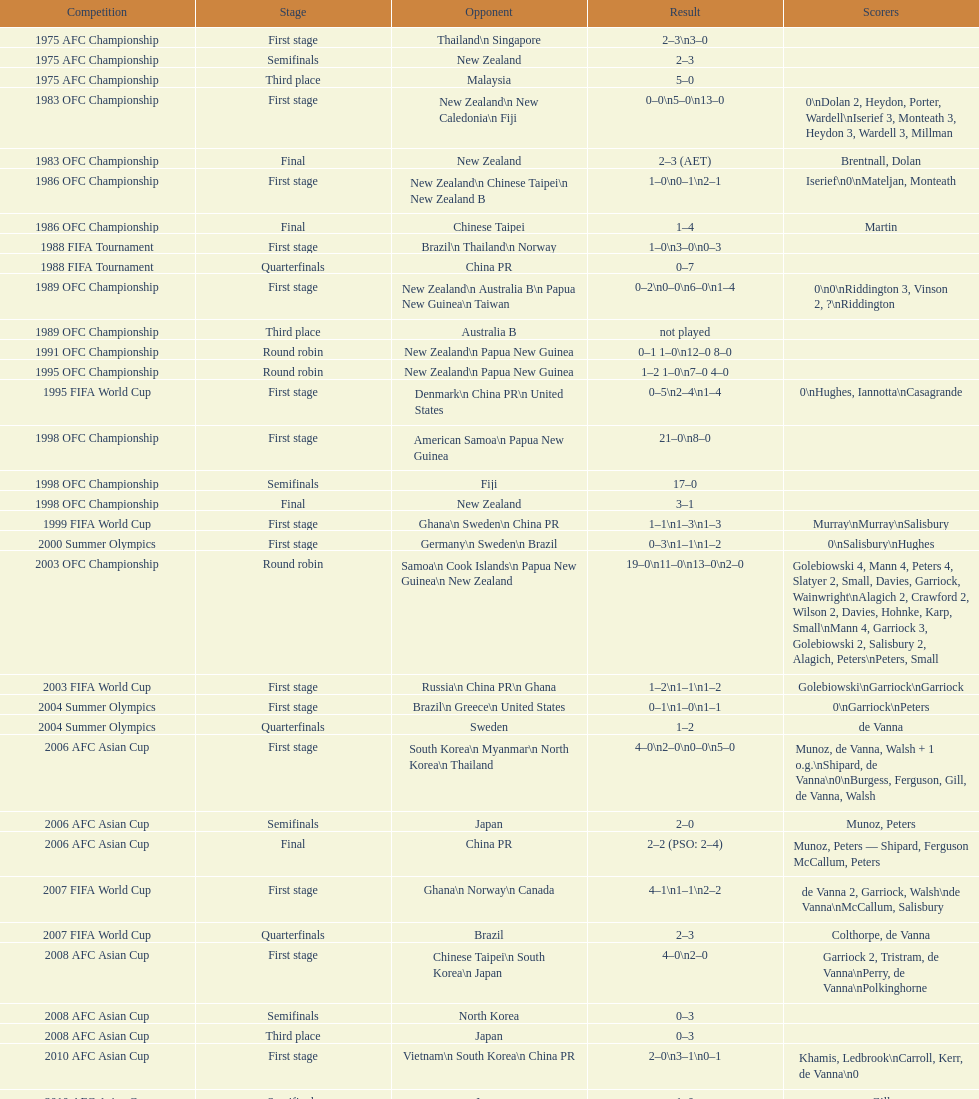In the 1983 ofc championship, how many goals were made in total? 18. 